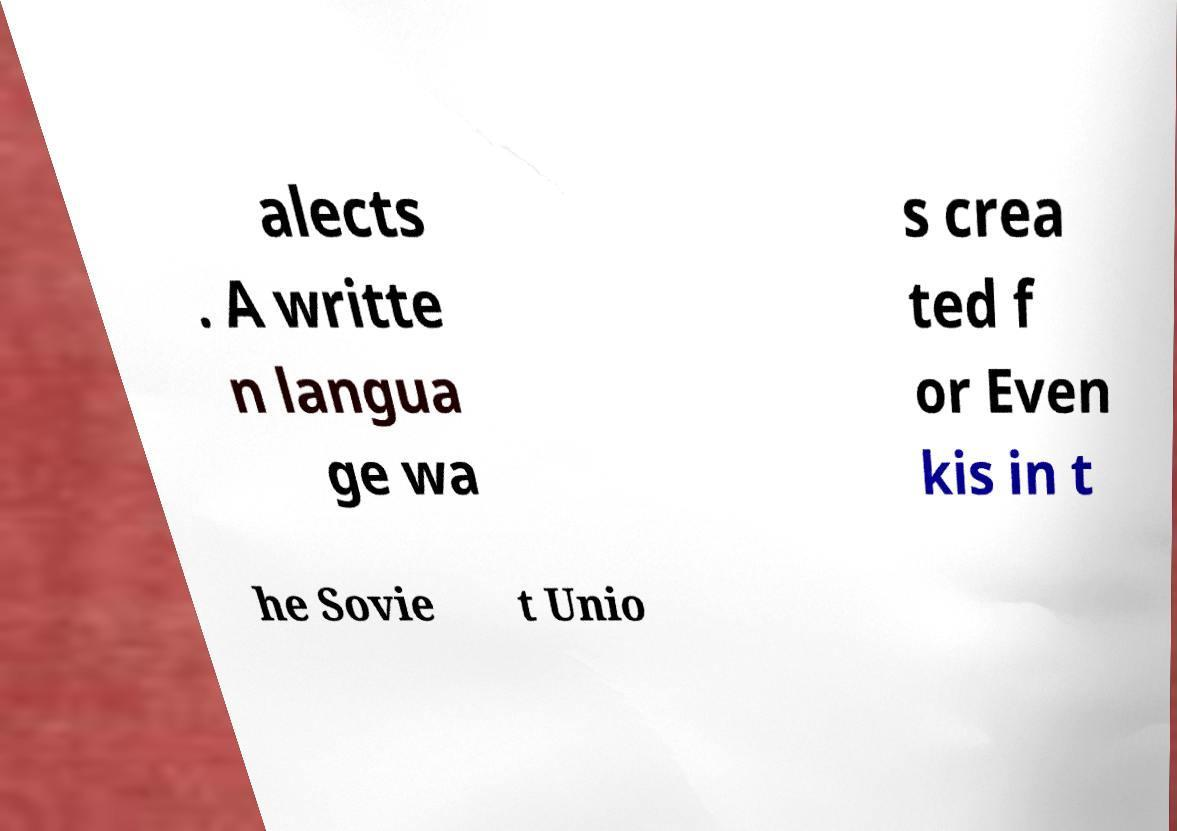Could you assist in decoding the text presented in this image and type it out clearly? alects . A writte n langua ge wa s crea ted f or Even kis in t he Sovie t Unio 